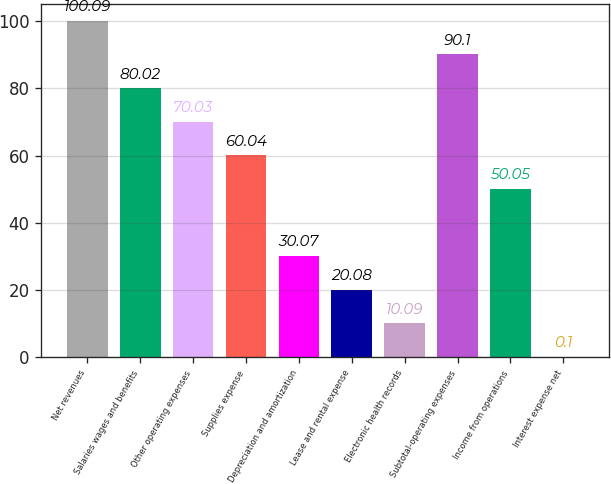<chart> <loc_0><loc_0><loc_500><loc_500><bar_chart><fcel>Net revenues<fcel>Salaries wages and benefits<fcel>Other operating expenses<fcel>Supplies expense<fcel>Depreciation and amortization<fcel>Lease and rental expense<fcel>Electronic health records<fcel>Subtotal-operating expenses<fcel>Income from operations<fcel>Interest expense net<nl><fcel>100.09<fcel>80.02<fcel>70.03<fcel>60.04<fcel>30.07<fcel>20.08<fcel>10.09<fcel>90.1<fcel>50.05<fcel>0.1<nl></chart> 